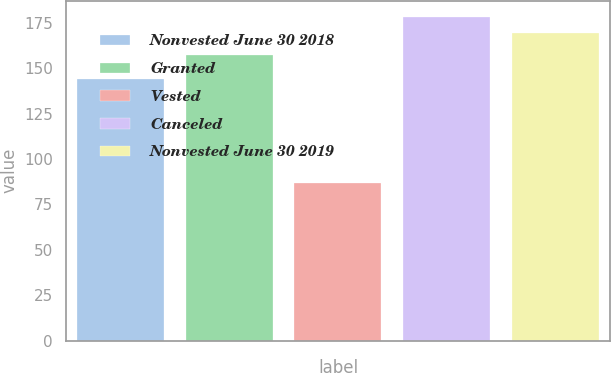Convert chart to OTSL. <chart><loc_0><loc_0><loc_500><loc_500><bar_chart><fcel>Nonvested June 30 2018<fcel>Granted<fcel>Vested<fcel>Canceled<fcel>Nonvested June 30 2019<nl><fcel>143.9<fcel>157.2<fcel>86.51<fcel>178.11<fcel>169.36<nl></chart> 